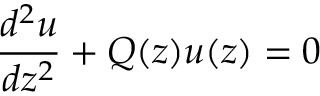<formula> <loc_0><loc_0><loc_500><loc_500>{ \frac { d ^ { 2 } u } { d z ^ { 2 } } } + Q ( z ) u ( z ) = 0</formula> 